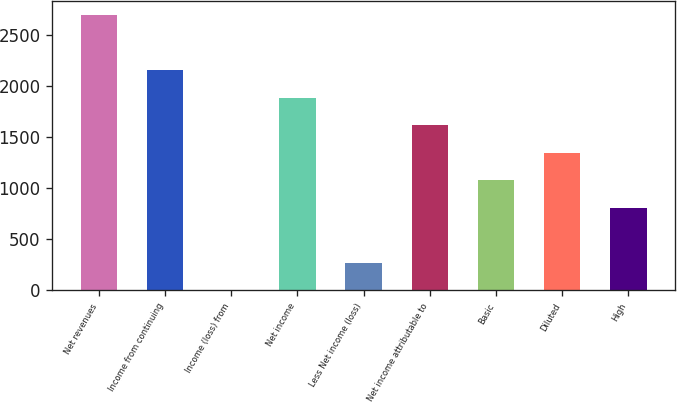Convert chart to OTSL. <chart><loc_0><loc_0><loc_500><loc_500><bar_chart><fcel>Net revenues<fcel>Income from continuing<fcel>Income (loss) from<fcel>Net income<fcel>Less Net income (loss)<fcel>Net income attributable to<fcel>Basic<fcel>Diluted<fcel>High<nl><fcel>2691<fcel>2153<fcel>1<fcel>1884<fcel>270<fcel>1615<fcel>1077<fcel>1346<fcel>808<nl></chart> 